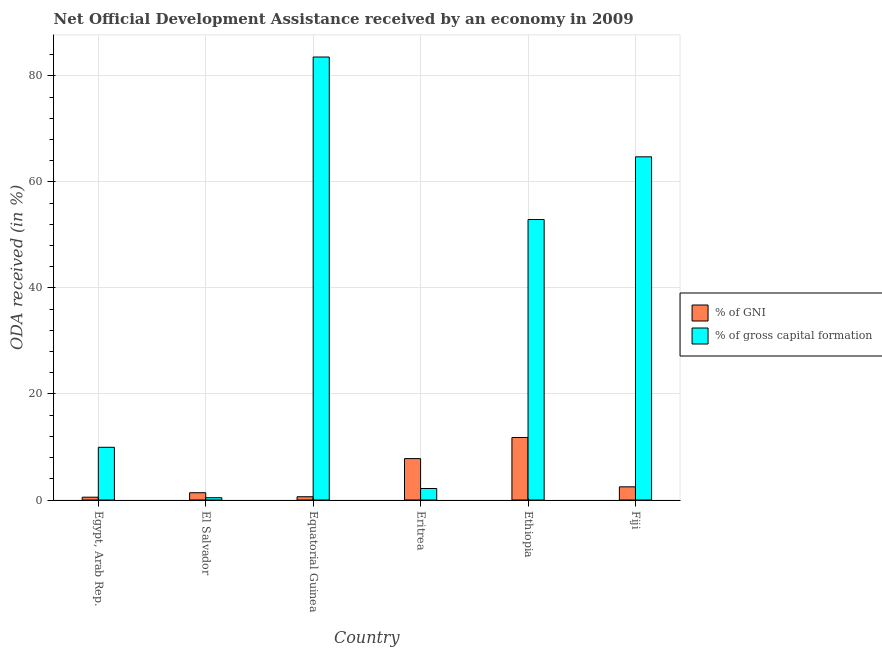How many different coloured bars are there?
Your answer should be compact. 2. Are the number of bars on each tick of the X-axis equal?
Your answer should be compact. Yes. How many bars are there on the 4th tick from the right?
Your answer should be compact. 2. What is the label of the 2nd group of bars from the left?
Provide a succinct answer. El Salvador. What is the oda received as percentage of gni in Eritrea?
Provide a short and direct response. 7.81. Across all countries, what is the maximum oda received as percentage of gni?
Provide a succinct answer. 11.79. Across all countries, what is the minimum oda received as percentage of gross capital formation?
Your response must be concise. 0.43. In which country was the oda received as percentage of gni maximum?
Provide a short and direct response. Ethiopia. In which country was the oda received as percentage of gni minimum?
Your answer should be compact. Egypt, Arab Rep. What is the total oda received as percentage of gni in the graph?
Give a very brief answer. 24.59. What is the difference between the oda received as percentage of gni in El Salvador and that in Fiji?
Your answer should be compact. -1.11. What is the difference between the oda received as percentage of gross capital formation in Fiji and the oda received as percentage of gni in Egypt, Arab Rep.?
Make the answer very short. 64.19. What is the average oda received as percentage of gross capital formation per country?
Provide a succinct answer. 35.62. What is the difference between the oda received as percentage of gni and oda received as percentage of gross capital formation in Ethiopia?
Your response must be concise. -41.11. What is the ratio of the oda received as percentage of gross capital formation in El Salvador to that in Eritrea?
Provide a succinct answer. 0.2. Is the oda received as percentage of gni in El Salvador less than that in Ethiopia?
Your answer should be very brief. Yes. What is the difference between the highest and the second highest oda received as percentage of gross capital formation?
Your answer should be compact. 18.82. What is the difference between the highest and the lowest oda received as percentage of gni?
Give a very brief answer. 11.26. In how many countries, is the oda received as percentage of gross capital formation greater than the average oda received as percentage of gross capital formation taken over all countries?
Ensure brevity in your answer.  3. What does the 2nd bar from the left in Equatorial Guinea represents?
Give a very brief answer. % of gross capital formation. What does the 2nd bar from the right in Eritrea represents?
Your answer should be very brief. % of GNI. What is the difference between two consecutive major ticks on the Y-axis?
Provide a short and direct response. 20. Does the graph contain any zero values?
Keep it short and to the point. No. Where does the legend appear in the graph?
Offer a terse response. Center right. What is the title of the graph?
Provide a short and direct response. Net Official Development Assistance received by an economy in 2009. What is the label or title of the Y-axis?
Provide a succinct answer. ODA received (in %). What is the ODA received (in %) of % of GNI in Egypt, Arab Rep.?
Your answer should be very brief. 0.53. What is the ODA received (in %) in % of gross capital formation in Egypt, Arab Rep.?
Your answer should be very brief. 9.94. What is the ODA received (in %) in % of GNI in El Salvador?
Offer a terse response. 1.37. What is the ODA received (in %) of % of gross capital formation in El Salvador?
Give a very brief answer. 0.43. What is the ODA received (in %) of % of GNI in Equatorial Guinea?
Keep it short and to the point. 0.61. What is the ODA received (in %) in % of gross capital formation in Equatorial Guinea?
Your answer should be very brief. 83.54. What is the ODA received (in %) of % of GNI in Eritrea?
Make the answer very short. 7.81. What is the ODA received (in %) in % of gross capital formation in Eritrea?
Provide a short and direct response. 2.17. What is the ODA received (in %) in % of GNI in Ethiopia?
Give a very brief answer. 11.79. What is the ODA received (in %) of % of gross capital formation in Ethiopia?
Your answer should be compact. 52.9. What is the ODA received (in %) in % of GNI in Fiji?
Give a very brief answer. 2.48. What is the ODA received (in %) of % of gross capital formation in Fiji?
Give a very brief answer. 64.72. Across all countries, what is the maximum ODA received (in %) of % of GNI?
Keep it short and to the point. 11.79. Across all countries, what is the maximum ODA received (in %) of % of gross capital formation?
Your answer should be very brief. 83.54. Across all countries, what is the minimum ODA received (in %) of % of GNI?
Make the answer very short. 0.53. Across all countries, what is the minimum ODA received (in %) of % of gross capital formation?
Your answer should be compact. 0.43. What is the total ODA received (in %) of % of GNI in the graph?
Make the answer very short. 24.59. What is the total ODA received (in %) of % of gross capital formation in the graph?
Provide a short and direct response. 213.7. What is the difference between the ODA received (in %) in % of GNI in Egypt, Arab Rep. and that in El Salvador?
Make the answer very short. -0.84. What is the difference between the ODA received (in %) of % of gross capital formation in Egypt, Arab Rep. and that in El Salvador?
Keep it short and to the point. 9.51. What is the difference between the ODA received (in %) in % of GNI in Egypt, Arab Rep. and that in Equatorial Guinea?
Your answer should be compact. -0.09. What is the difference between the ODA received (in %) in % of gross capital formation in Egypt, Arab Rep. and that in Equatorial Guinea?
Your answer should be very brief. -73.6. What is the difference between the ODA received (in %) of % of GNI in Egypt, Arab Rep. and that in Eritrea?
Your response must be concise. -7.28. What is the difference between the ODA received (in %) of % of gross capital formation in Egypt, Arab Rep. and that in Eritrea?
Your answer should be compact. 7.78. What is the difference between the ODA received (in %) of % of GNI in Egypt, Arab Rep. and that in Ethiopia?
Keep it short and to the point. -11.26. What is the difference between the ODA received (in %) of % of gross capital formation in Egypt, Arab Rep. and that in Ethiopia?
Your answer should be very brief. -42.96. What is the difference between the ODA received (in %) in % of GNI in Egypt, Arab Rep. and that in Fiji?
Offer a very short reply. -1.95. What is the difference between the ODA received (in %) in % of gross capital formation in Egypt, Arab Rep. and that in Fiji?
Make the answer very short. -54.78. What is the difference between the ODA received (in %) in % of GNI in El Salvador and that in Equatorial Guinea?
Offer a terse response. 0.76. What is the difference between the ODA received (in %) of % of gross capital formation in El Salvador and that in Equatorial Guinea?
Give a very brief answer. -83.11. What is the difference between the ODA received (in %) in % of GNI in El Salvador and that in Eritrea?
Make the answer very short. -6.43. What is the difference between the ODA received (in %) of % of gross capital formation in El Salvador and that in Eritrea?
Your response must be concise. -1.73. What is the difference between the ODA received (in %) of % of GNI in El Salvador and that in Ethiopia?
Ensure brevity in your answer.  -10.42. What is the difference between the ODA received (in %) of % of gross capital formation in El Salvador and that in Ethiopia?
Give a very brief answer. -52.47. What is the difference between the ODA received (in %) in % of GNI in El Salvador and that in Fiji?
Your response must be concise. -1.11. What is the difference between the ODA received (in %) in % of gross capital formation in El Salvador and that in Fiji?
Offer a terse response. -64.29. What is the difference between the ODA received (in %) in % of GNI in Equatorial Guinea and that in Eritrea?
Your response must be concise. -7.19. What is the difference between the ODA received (in %) in % of gross capital formation in Equatorial Guinea and that in Eritrea?
Your answer should be compact. 81.37. What is the difference between the ODA received (in %) of % of GNI in Equatorial Guinea and that in Ethiopia?
Your answer should be very brief. -11.17. What is the difference between the ODA received (in %) of % of gross capital formation in Equatorial Guinea and that in Ethiopia?
Offer a terse response. 30.64. What is the difference between the ODA received (in %) of % of GNI in Equatorial Guinea and that in Fiji?
Provide a succinct answer. -1.87. What is the difference between the ODA received (in %) of % of gross capital formation in Equatorial Guinea and that in Fiji?
Offer a very short reply. 18.82. What is the difference between the ODA received (in %) of % of GNI in Eritrea and that in Ethiopia?
Offer a very short reply. -3.98. What is the difference between the ODA received (in %) of % of gross capital formation in Eritrea and that in Ethiopia?
Offer a very short reply. -50.73. What is the difference between the ODA received (in %) in % of GNI in Eritrea and that in Fiji?
Offer a terse response. 5.32. What is the difference between the ODA received (in %) in % of gross capital formation in Eritrea and that in Fiji?
Keep it short and to the point. -62.55. What is the difference between the ODA received (in %) in % of GNI in Ethiopia and that in Fiji?
Offer a terse response. 9.31. What is the difference between the ODA received (in %) of % of gross capital formation in Ethiopia and that in Fiji?
Keep it short and to the point. -11.82. What is the difference between the ODA received (in %) of % of GNI in Egypt, Arab Rep. and the ODA received (in %) of % of gross capital formation in El Salvador?
Keep it short and to the point. 0.1. What is the difference between the ODA received (in %) of % of GNI in Egypt, Arab Rep. and the ODA received (in %) of % of gross capital formation in Equatorial Guinea?
Your response must be concise. -83.01. What is the difference between the ODA received (in %) in % of GNI in Egypt, Arab Rep. and the ODA received (in %) in % of gross capital formation in Eritrea?
Offer a very short reply. -1.64. What is the difference between the ODA received (in %) of % of GNI in Egypt, Arab Rep. and the ODA received (in %) of % of gross capital formation in Ethiopia?
Provide a short and direct response. -52.37. What is the difference between the ODA received (in %) of % of GNI in Egypt, Arab Rep. and the ODA received (in %) of % of gross capital formation in Fiji?
Your response must be concise. -64.19. What is the difference between the ODA received (in %) of % of GNI in El Salvador and the ODA received (in %) of % of gross capital formation in Equatorial Guinea?
Your answer should be compact. -82.17. What is the difference between the ODA received (in %) in % of GNI in El Salvador and the ODA received (in %) in % of gross capital formation in Eritrea?
Make the answer very short. -0.79. What is the difference between the ODA received (in %) in % of GNI in El Salvador and the ODA received (in %) in % of gross capital formation in Ethiopia?
Offer a very short reply. -51.53. What is the difference between the ODA received (in %) in % of GNI in El Salvador and the ODA received (in %) in % of gross capital formation in Fiji?
Offer a very short reply. -63.35. What is the difference between the ODA received (in %) of % of GNI in Equatorial Guinea and the ODA received (in %) of % of gross capital formation in Eritrea?
Your answer should be very brief. -1.55. What is the difference between the ODA received (in %) of % of GNI in Equatorial Guinea and the ODA received (in %) of % of gross capital formation in Ethiopia?
Keep it short and to the point. -52.28. What is the difference between the ODA received (in %) in % of GNI in Equatorial Guinea and the ODA received (in %) in % of gross capital formation in Fiji?
Keep it short and to the point. -64.11. What is the difference between the ODA received (in %) in % of GNI in Eritrea and the ODA received (in %) in % of gross capital formation in Ethiopia?
Make the answer very short. -45.09. What is the difference between the ODA received (in %) of % of GNI in Eritrea and the ODA received (in %) of % of gross capital formation in Fiji?
Offer a terse response. -56.91. What is the difference between the ODA received (in %) in % of GNI in Ethiopia and the ODA received (in %) in % of gross capital formation in Fiji?
Offer a very short reply. -52.93. What is the average ODA received (in %) of % of GNI per country?
Give a very brief answer. 4.1. What is the average ODA received (in %) of % of gross capital formation per country?
Your answer should be compact. 35.62. What is the difference between the ODA received (in %) in % of GNI and ODA received (in %) in % of gross capital formation in Egypt, Arab Rep.?
Provide a succinct answer. -9.41. What is the difference between the ODA received (in %) in % of GNI and ODA received (in %) in % of gross capital formation in El Salvador?
Offer a terse response. 0.94. What is the difference between the ODA received (in %) in % of GNI and ODA received (in %) in % of gross capital formation in Equatorial Guinea?
Your answer should be very brief. -82.93. What is the difference between the ODA received (in %) of % of GNI and ODA received (in %) of % of gross capital formation in Eritrea?
Provide a short and direct response. 5.64. What is the difference between the ODA received (in %) of % of GNI and ODA received (in %) of % of gross capital formation in Ethiopia?
Your answer should be very brief. -41.11. What is the difference between the ODA received (in %) in % of GNI and ODA received (in %) in % of gross capital formation in Fiji?
Provide a short and direct response. -62.24. What is the ratio of the ODA received (in %) of % of GNI in Egypt, Arab Rep. to that in El Salvador?
Your answer should be compact. 0.39. What is the ratio of the ODA received (in %) in % of gross capital formation in Egypt, Arab Rep. to that in El Salvador?
Give a very brief answer. 22.99. What is the ratio of the ODA received (in %) of % of GNI in Egypt, Arab Rep. to that in Equatorial Guinea?
Provide a short and direct response. 0.86. What is the ratio of the ODA received (in %) of % of gross capital formation in Egypt, Arab Rep. to that in Equatorial Guinea?
Provide a short and direct response. 0.12. What is the ratio of the ODA received (in %) in % of GNI in Egypt, Arab Rep. to that in Eritrea?
Provide a succinct answer. 0.07. What is the ratio of the ODA received (in %) in % of gross capital formation in Egypt, Arab Rep. to that in Eritrea?
Provide a short and direct response. 4.59. What is the ratio of the ODA received (in %) of % of GNI in Egypt, Arab Rep. to that in Ethiopia?
Give a very brief answer. 0.04. What is the ratio of the ODA received (in %) in % of gross capital formation in Egypt, Arab Rep. to that in Ethiopia?
Keep it short and to the point. 0.19. What is the ratio of the ODA received (in %) in % of GNI in Egypt, Arab Rep. to that in Fiji?
Offer a terse response. 0.21. What is the ratio of the ODA received (in %) in % of gross capital formation in Egypt, Arab Rep. to that in Fiji?
Keep it short and to the point. 0.15. What is the ratio of the ODA received (in %) of % of GNI in El Salvador to that in Equatorial Guinea?
Ensure brevity in your answer.  2.24. What is the ratio of the ODA received (in %) of % of gross capital formation in El Salvador to that in Equatorial Guinea?
Provide a short and direct response. 0.01. What is the ratio of the ODA received (in %) of % of GNI in El Salvador to that in Eritrea?
Your answer should be compact. 0.18. What is the ratio of the ODA received (in %) of % of gross capital formation in El Salvador to that in Eritrea?
Your answer should be compact. 0.2. What is the ratio of the ODA received (in %) of % of GNI in El Salvador to that in Ethiopia?
Offer a very short reply. 0.12. What is the ratio of the ODA received (in %) in % of gross capital formation in El Salvador to that in Ethiopia?
Ensure brevity in your answer.  0.01. What is the ratio of the ODA received (in %) of % of GNI in El Salvador to that in Fiji?
Give a very brief answer. 0.55. What is the ratio of the ODA received (in %) in % of gross capital formation in El Salvador to that in Fiji?
Provide a succinct answer. 0.01. What is the ratio of the ODA received (in %) of % of GNI in Equatorial Guinea to that in Eritrea?
Keep it short and to the point. 0.08. What is the ratio of the ODA received (in %) of % of gross capital formation in Equatorial Guinea to that in Eritrea?
Give a very brief answer. 38.55. What is the ratio of the ODA received (in %) in % of GNI in Equatorial Guinea to that in Ethiopia?
Your answer should be very brief. 0.05. What is the ratio of the ODA received (in %) in % of gross capital formation in Equatorial Guinea to that in Ethiopia?
Give a very brief answer. 1.58. What is the ratio of the ODA received (in %) in % of GNI in Equatorial Guinea to that in Fiji?
Provide a short and direct response. 0.25. What is the ratio of the ODA received (in %) in % of gross capital formation in Equatorial Guinea to that in Fiji?
Your answer should be very brief. 1.29. What is the ratio of the ODA received (in %) of % of GNI in Eritrea to that in Ethiopia?
Make the answer very short. 0.66. What is the ratio of the ODA received (in %) in % of gross capital formation in Eritrea to that in Ethiopia?
Give a very brief answer. 0.04. What is the ratio of the ODA received (in %) in % of GNI in Eritrea to that in Fiji?
Ensure brevity in your answer.  3.14. What is the ratio of the ODA received (in %) of % of gross capital formation in Eritrea to that in Fiji?
Provide a short and direct response. 0.03. What is the ratio of the ODA received (in %) in % of GNI in Ethiopia to that in Fiji?
Your answer should be very brief. 4.75. What is the ratio of the ODA received (in %) of % of gross capital formation in Ethiopia to that in Fiji?
Make the answer very short. 0.82. What is the difference between the highest and the second highest ODA received (in %) of % of GNI?
Provide a short and direct response. 3.98. What is the difference between the highest and the second highest ODA received (in %) in % of gross capital formation?
Ensure brevity in your answer.  18.82. What is the difference between the highest and the lowest ODA received (in %) of % of GNI?
Provide a succinct answer. 11.26. What is the difference between the highest and the lowest ODA received (in %) in % of gross capital formation?
Your response must be concise. 83.11. 